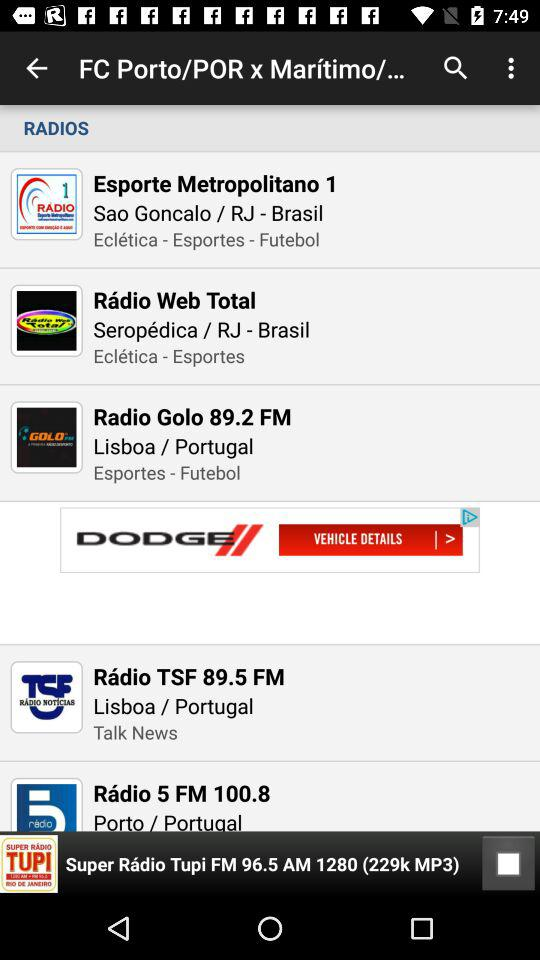Which radio station was last played? The last played radio station was "Super Rádio Tupi FM 96.5 AM 1280". 